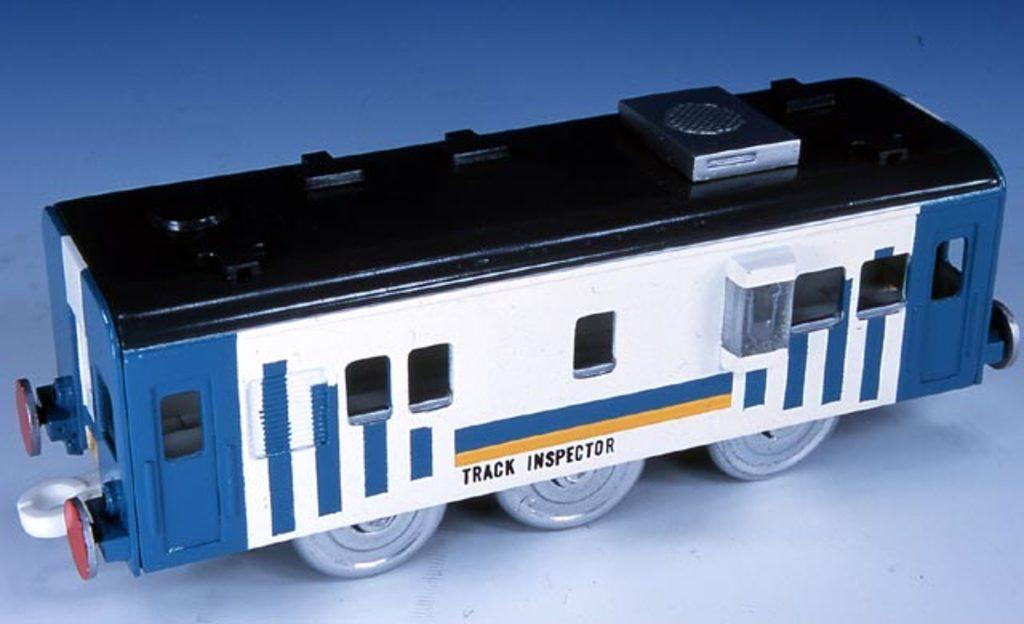What is the main subject of the image? The main subject of the image is a miniature railway engine. What colors can be seen on the railway engine? The railway engine is black, white, and blue in color. What is the surface beneath the railway engine? The miniature railway engine is on a white surface. Can you hear the sound of the railway engine in the image? The image is static, so there is no sound associated with it. Therefore, it is not possible to hear the sound of the railway engine in the image. 